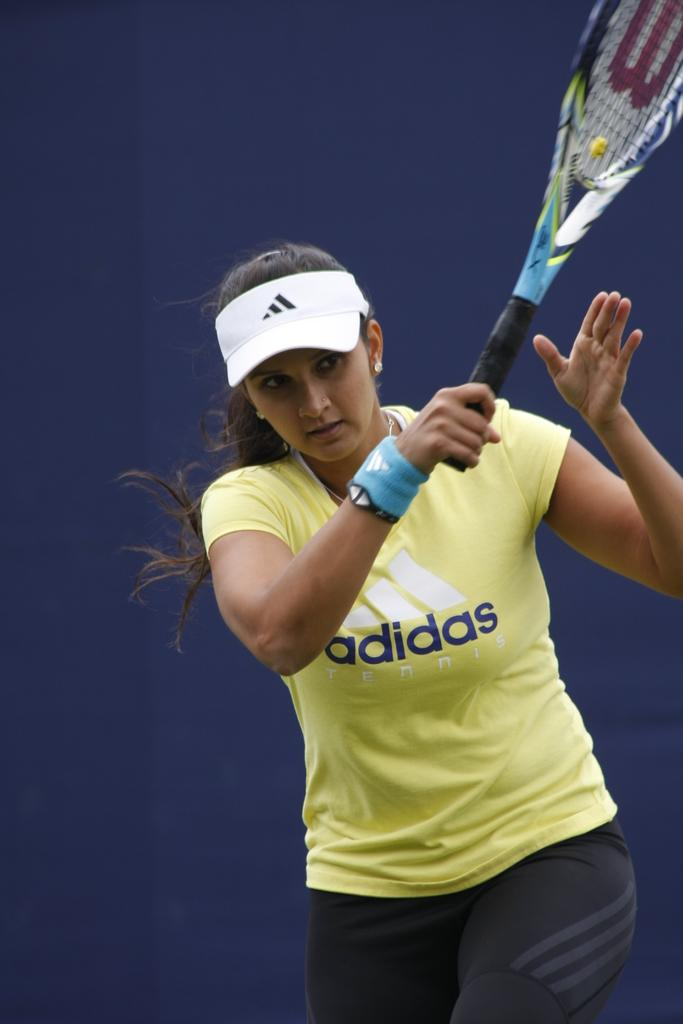Who is the main subject in the image? There is a woman in the image. What is the woman wearing in the image? The woman is wearing a yellow t-shirt. Can you identify the brand of the t-shirt? Yes, the t-shirt brand is Adidas. What is the woman holding in the image? The woman is holding a tennis racket. What color is the background of the image? The background of the image is a blue color wall. How many people are in the crowd behind the woman in the image? There is no crowd present in the image; it only features the woman holding a tennis racket against a blue color wall. What type of vest is the woman wearing in the image? The woman is not wearing a vest in the image; she is wearing a yellow t-shirt. 